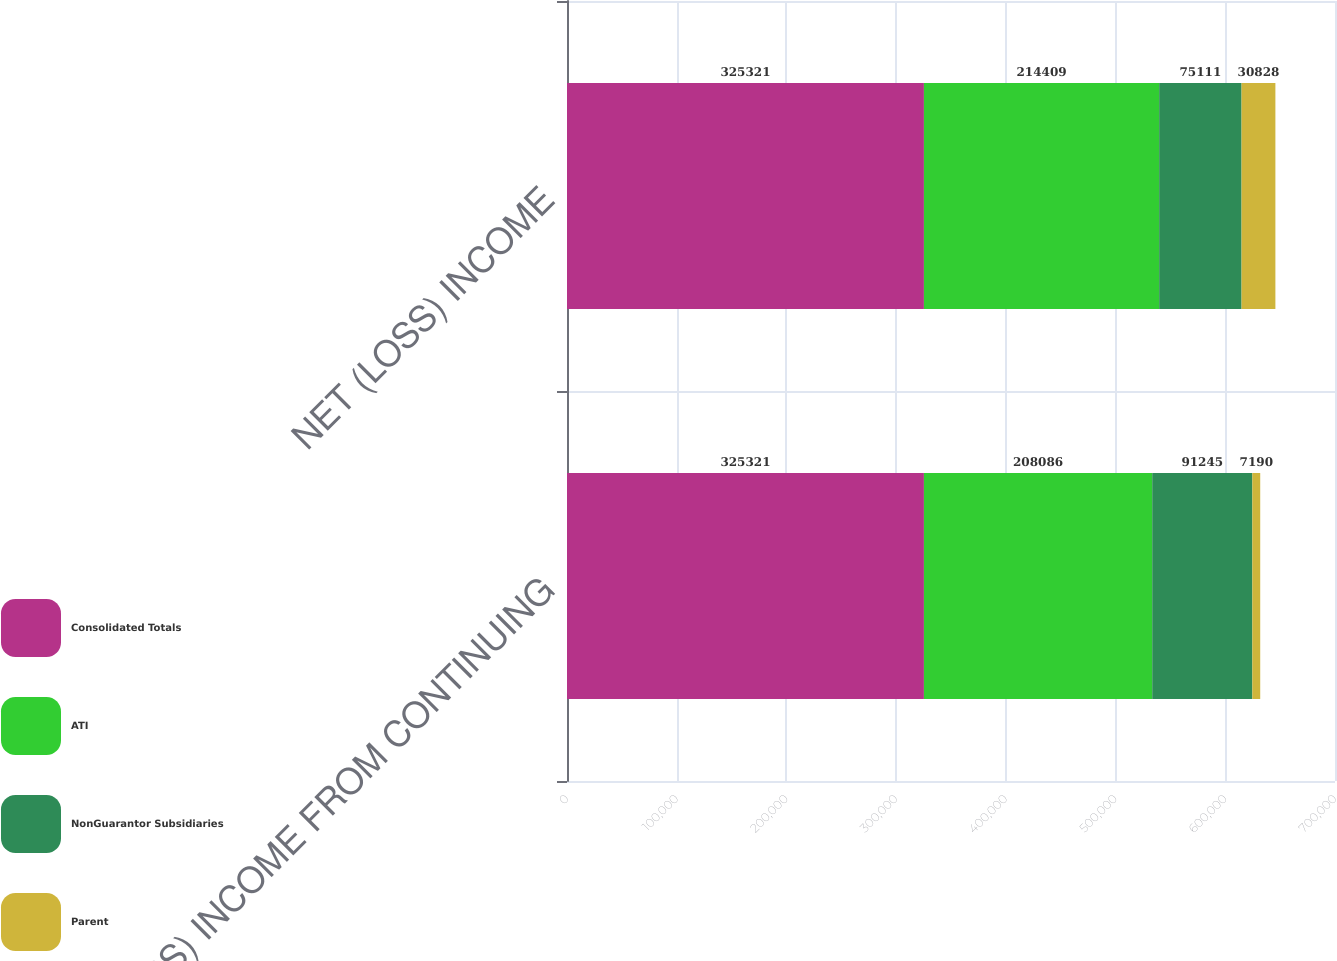<chart> <loc_0><loc_0><loc_500><loc_500><stacked_bar_chart><ecel><fcel>(LOSS) INCOME FROM CONTINUING<fcel>NET (LOSS) INCOME<nl><fcel>Consolidated Totals<fcel>325321<fcel>325321<nl><fcel>ATI<fcel>208086<fcel>214409<nl><fcel>NonGuarantor Subsidiaries<fcel>91245<fcel>75111<nl><fcel>Parent<fcel>7190<fcel>30828<nl></chart> 